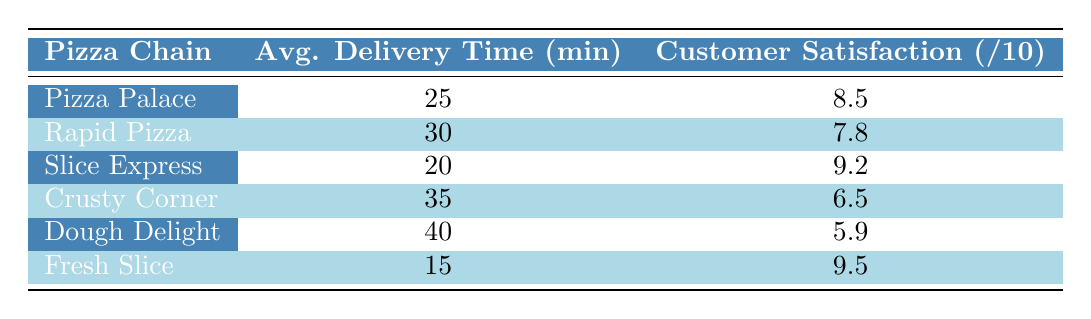What is the customer satisfaction rating for Fresh Slice? The table lists Fresh Slice with a customer satisfaction rating of 9.5 out of 10. This value can be found directly in the corresponding row for Fresh Slice.
Answer: 9.5 Which pizza chain has the longest average delivery time? According to the table, Dough Delight has the longest average delivery time at 40 minutes, which is the highest number in that column.
Answer: Dough Delight What is the average customer satisfaction rating for all the pizza chains combined? To find the average rating, sum all the satisfaction ratings (8.5 + 7.8 + 9.2 + 6.5 + 5.9 + 9.5 = 47.4) and then divide by the number of pizza chains (6). The average is 47.4 / 6 = 7.9.
Answer: 7.9 Does Slice Express have a lower customer satisfaction rating than Rapid Pizza? The table shows Slice Express has a rating of 9.2, which is higher than Rapid Pizza's rating of 7.8. Therefore, the statement is false.
Answer: No If we compare the average delivery times, is there a difference of 15 minutes or more between Dough Delight and Fresh Slice? Dough Delight has an average delivery time of 40 minutes and Fresh Slice has 15 minutes. The difference is calculated as 40 - 15 = 25 minutes, which is indeed 15 minutes or more.
Answer: Yes Which pizza chain has the highest customer satisfaction rating and what is that rating? From the table, Fresh Slice has the highest customer satisfaction rating at 9.5. This can be confirmed by scanning through the ratings in the table.
Answer: Fresh Slice, 9.5 Are there any pizza chains that have an average delivery time of less than 30 minutes? The table indicates that Fresh Slice (15 minutes), Slice Express (20 minutes), and Pizza Palace (25 minutes) all have delivery times under 30 minutes. Hence, there are multiple chains that meet this criterion.
Answer: Yes What is the total average delivery time for the top three rated pizza chains? The top three rated pizza chains based on customer satisfaction are Fresh Slice (15 minutes), Slice Express (20 minutes), and Pizza Palace (25 minutes). Their total delivery time is 15 + 20 + 25 = 60 minutes and average delivery time is 60 / 3 = 20 minutes.
Answer: 20 